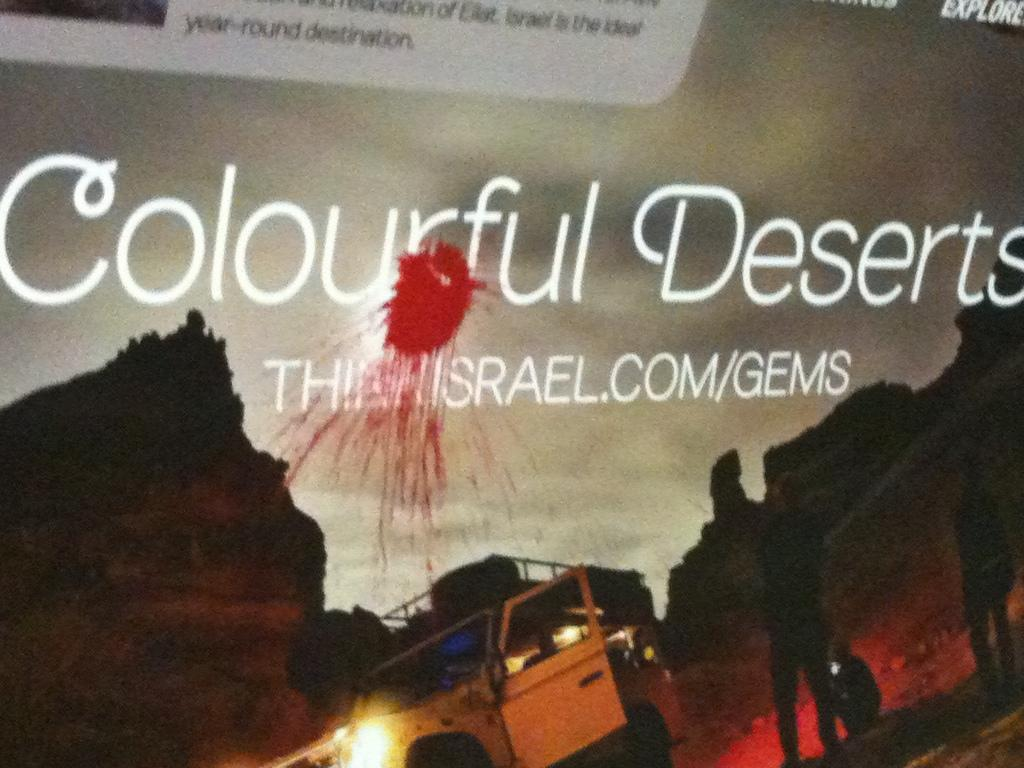<image>
Present a compact description of the photo's key features. A poster that says colorful deserts with a Jeep in the picture. 